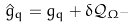Convert formula to latex. <formula><loc_0><loc_0><loc_500><loc_500>\hat { g } _ { q } = g _ { q } + \delta \mathcal { Q } _ { \Omega ^ { - } }</formula> 